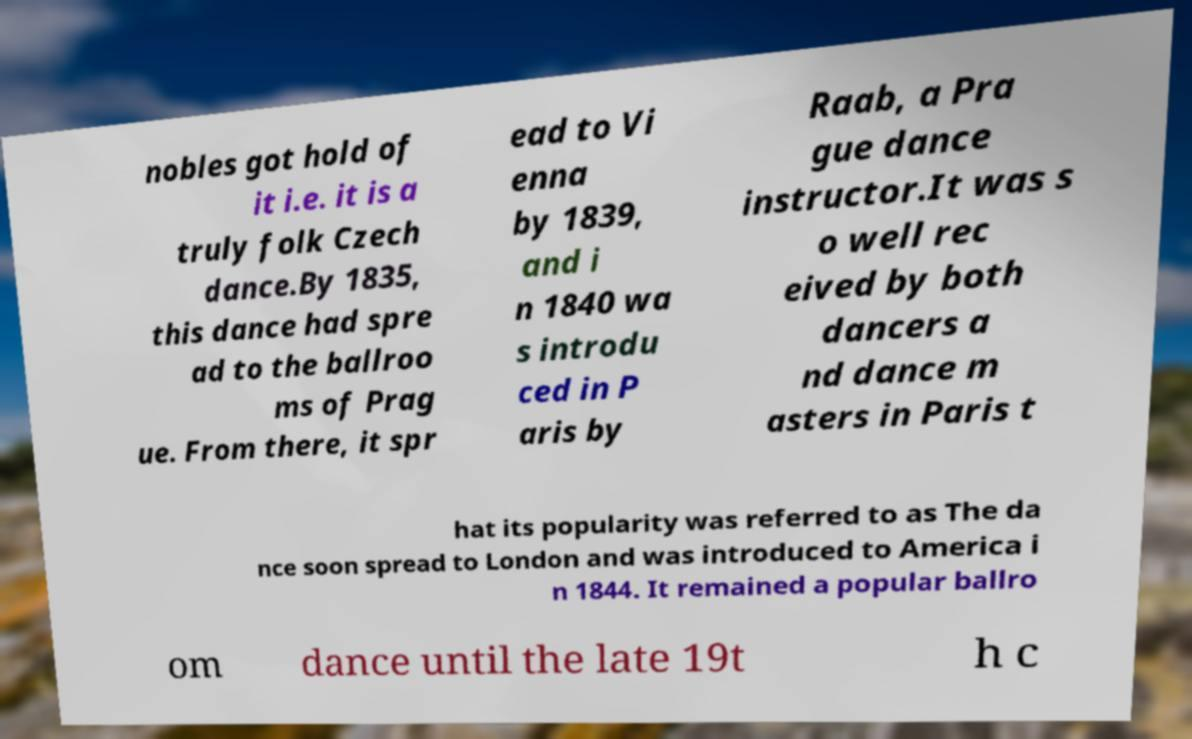Can you accurately transcribe the text from the provided image for me? nobles got hold of it i.e. it is a truly folk Czech dance.By 1835, this dance had spre ad to the ballroo ms of Prag ue. From there, it spr ead to Vi enna by 1839, and i n 1840 wa s introdu ced in P aris by Raab, a Pra gue dance instructor.It was s o well rec eived by both dancers a nd dance m asters in Paris t hat its popularity was referred to as The da nce soon spread to London and was introduced to America i n 1844. It remained a popular ballro om dance until the late 19t h c 